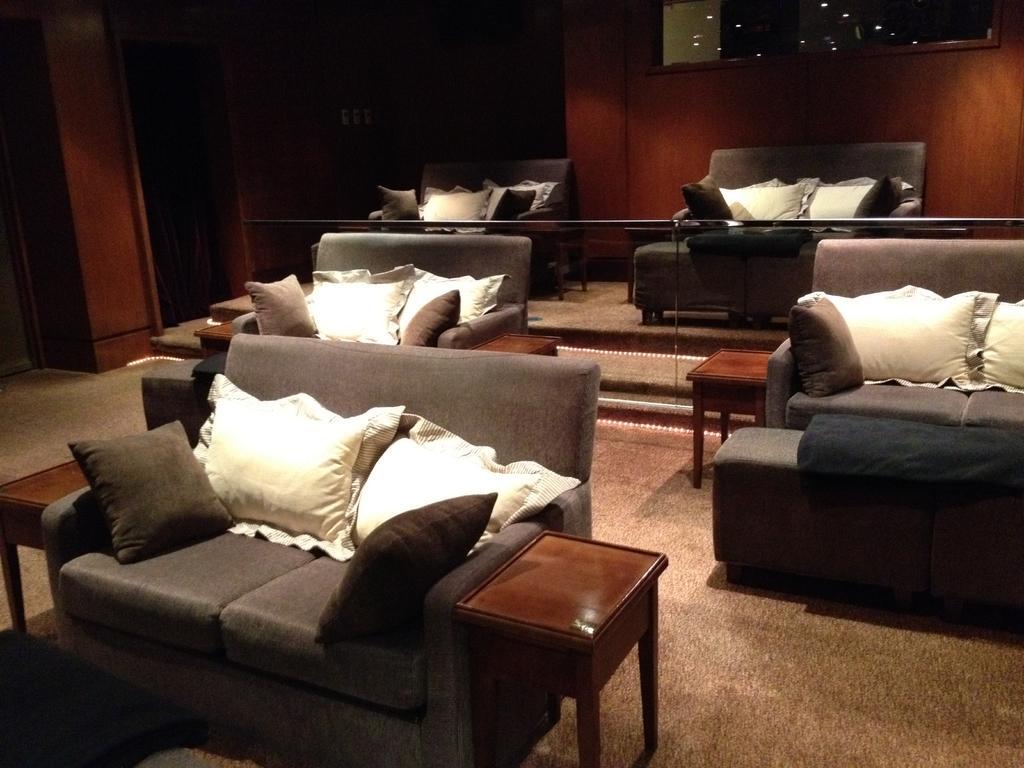In one or two sentences, can you explain what this image depicts? In the image we can see there are sofas which are kept in the room, there are cushions which are also kept on the sofa. The sofas are in ash colour and there is table kept behind the sofa. 